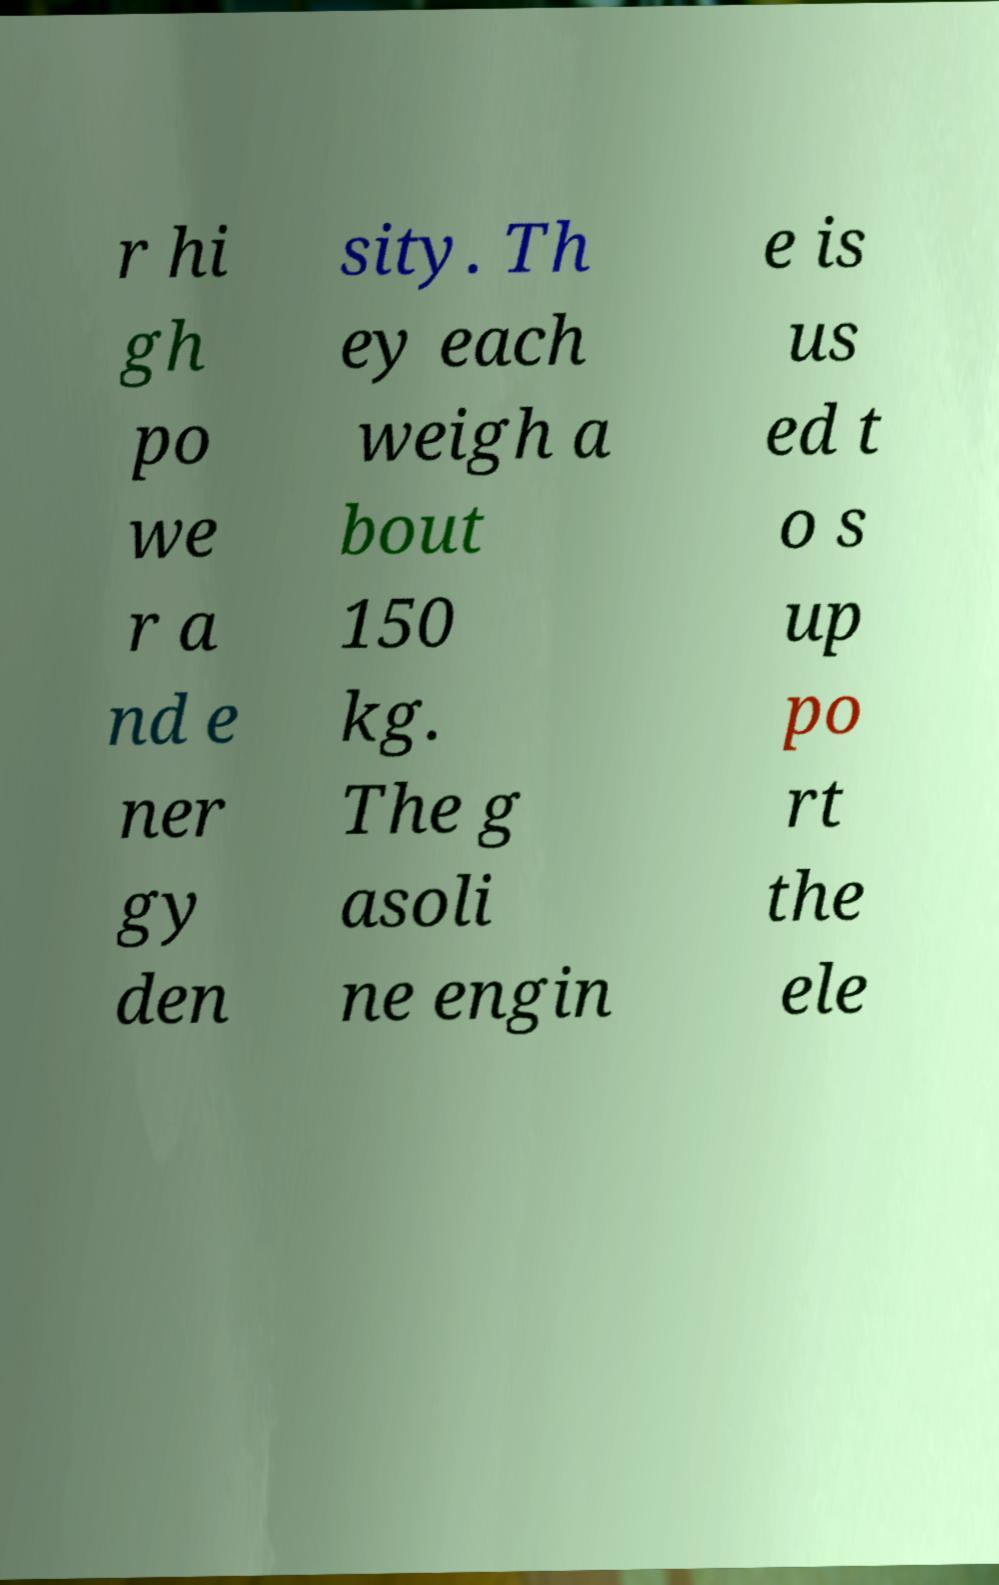There's text embedded in this image that I need extracted. Can you transcribe it verbatim? r hi gh po we r a nd e ner gy den sity. Th ey each weigh a bout 150 kg. The g asoli ne engin e is us ed t o s up po rt the ele 